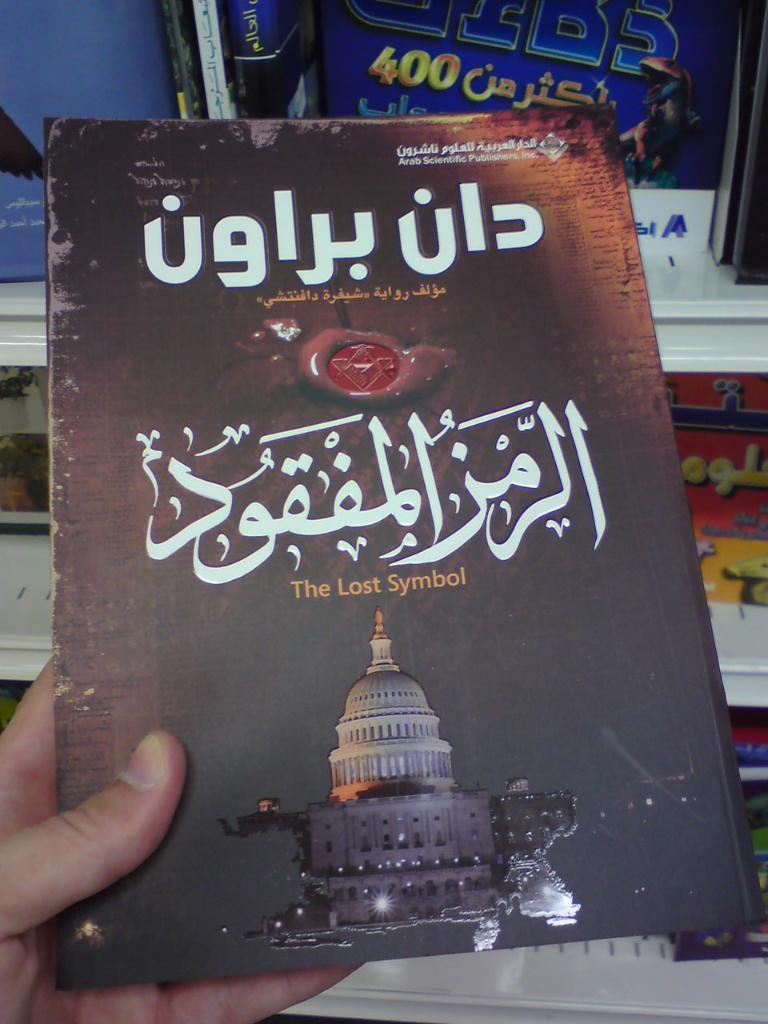Provide a one-sentence caption for the provided image. a book that appears to be old and it has arabic language on it. 